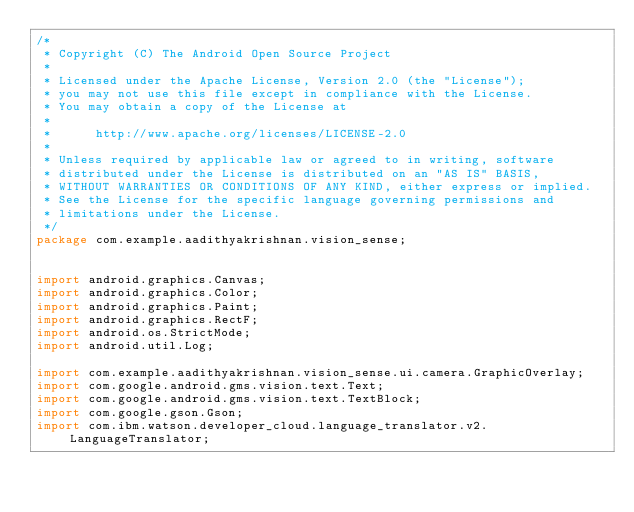Convert code to text. <code><loc_0><loc_0><loc_500><loc_500><_Java_>/*
 * Copyright (C) The Android Open Source Project
 *
 * Licensed under the Apache License, Version 2.0 (the "License");
 * you may not use this file except in compliance with the License.
 * You may obtain a copy of the License at
 *
 *      http://www.apache.org/licenses/LICENSE-2.0
 *
 * Unless required by applicable law or agreed to in writing, software
 * distributed under the License is distributed on an "AS IS" BASIS,
 * WITHOUT WARRANTIES OR CONDITIONS OF ANY KIND, either express or implied.
 * See the License for the specific language governing permissions and
 * limitations under the License.
 */
package com.example.aadithyakrishnan.vision_sense;


import android.graphics.Canvas;
import android.graphics.Color;
import android.graphics.Paint;
import android.graphics.RectF;
import android.os.StrictMode;
import android.util.Log;

import com.example.aadithyakrishnan.vision_sense.ui.camera.GraphicOverlay;
import com.google.android.gms.vision.text.Text;
import com.google.android.gms.vision.text.TextBlock;
import com.google.gson.Gson;
import com.ibm.watson.developer_cloud.language_translator.v2.LanguageTranslator;</code> 